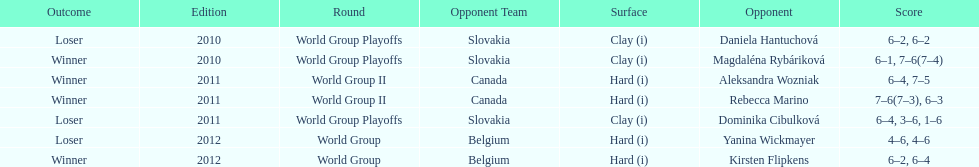Was the game versus canada later than the game versus belgium? No. 